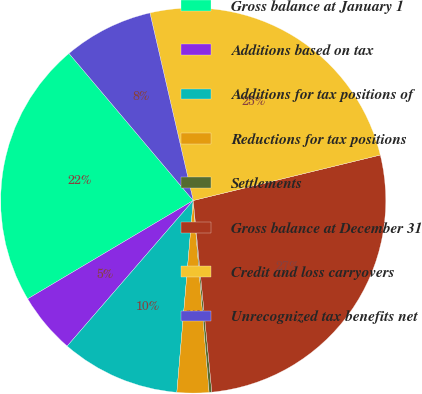Convert chart to OTSL. <chart><loc_0><loc_0><loc_500><loc_500><pie_chart><fcel>Gross balance at January 1<fcel>Additions based on tax<fcel>Additions for tax positions of<fcel>Reductions for tax positions<fcel>Settlements<fcel>Gross balance at December 31<fcel>Credit and loss carryovers<fcel>Unrecognized tax benefits net<nl><fcel>22.37%<fcel>5.11%<fcel>10.0%<fcel>2.67%<fcel>0.23%<fcel>27.25%<fcel>24.81%<fcel>7.55%<nl></chart> 